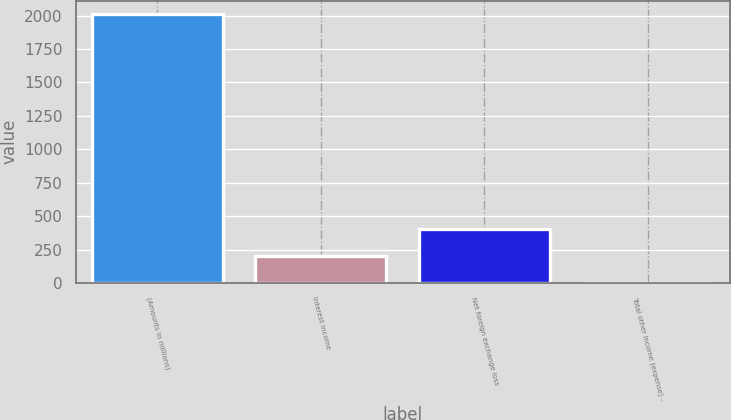<chart> <loc_0><loc_0><loc_500><loc_500><bar_chart><fcel>(Amounts in millions)<fcel>Interest income<fcel>Net foreign exchange loss<fcel>Total other income (expense) -<nl><fcel>2011<fcel>202<fcel>403<fcel>1<nl></chart> 